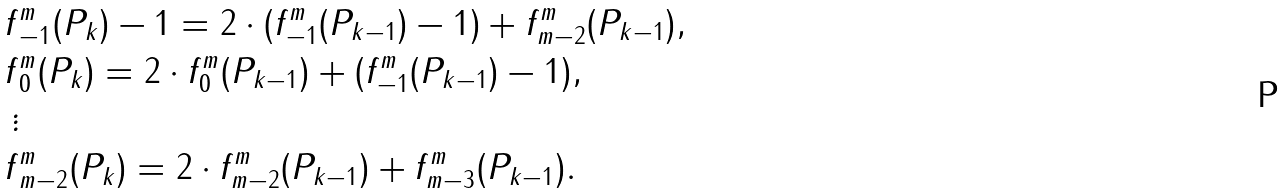<formula> <loc_0><loc_0><loc_500><loc_500>f & _ { - 1 } ^ { m } ( P _ { k } ) - 1 = 2 \cdot ( f _ { - 1 } ^ { m } ( P _ { k - 1 } ) - 1 ) + f _ { m - 2 } ^ { m } ( P _ { k - 1 } ) , \\ f & _ { 0 } ^ { m } ( P _ { k } ) = 2 \cdot f _ { 0 } ^ { m } ( P _ { k - 1 } ) + ( f _ { - 1 } ^ { m } ( P _ { k - 1 } ) - 1 ) , \\ \vdots \\ f & _ { m - 2 } ^ { m } ( P _ { k } ) = 2 \cdot f _ { m - 2 } ^ { m } ( P _ { k - 1 } ) + f _ { m - 3 } ^ { m } ( P _ { k - 1 } ) .</formula> 